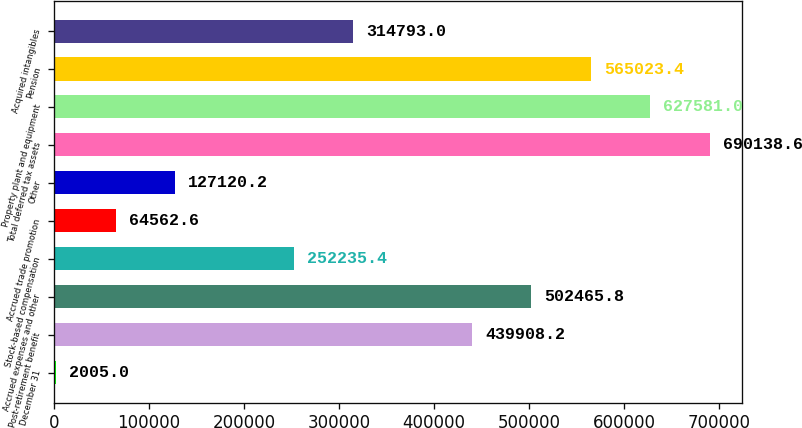<chart> <loc_0><loc_0><loc_500><loc_500><bar_chart><fcel>December 31<fcel>Post-retirement benefit<fcel>Accrued expenses and other<fcel>Stock-based compensation<fcel>Accrued trade promotion<fcel>Other<fcel>Total deferred tax assets<fcel>Property plant and equipment<fcel>Pension<fcel>Acquired intangibles<nl><fcel>2005<fcel>439908<fcel>502466<fcel>252235<fcel>64562.6<fcel>127120<fcel>690139<fcel>627581<fcel>565023<fcel>314793<nl></chart> 